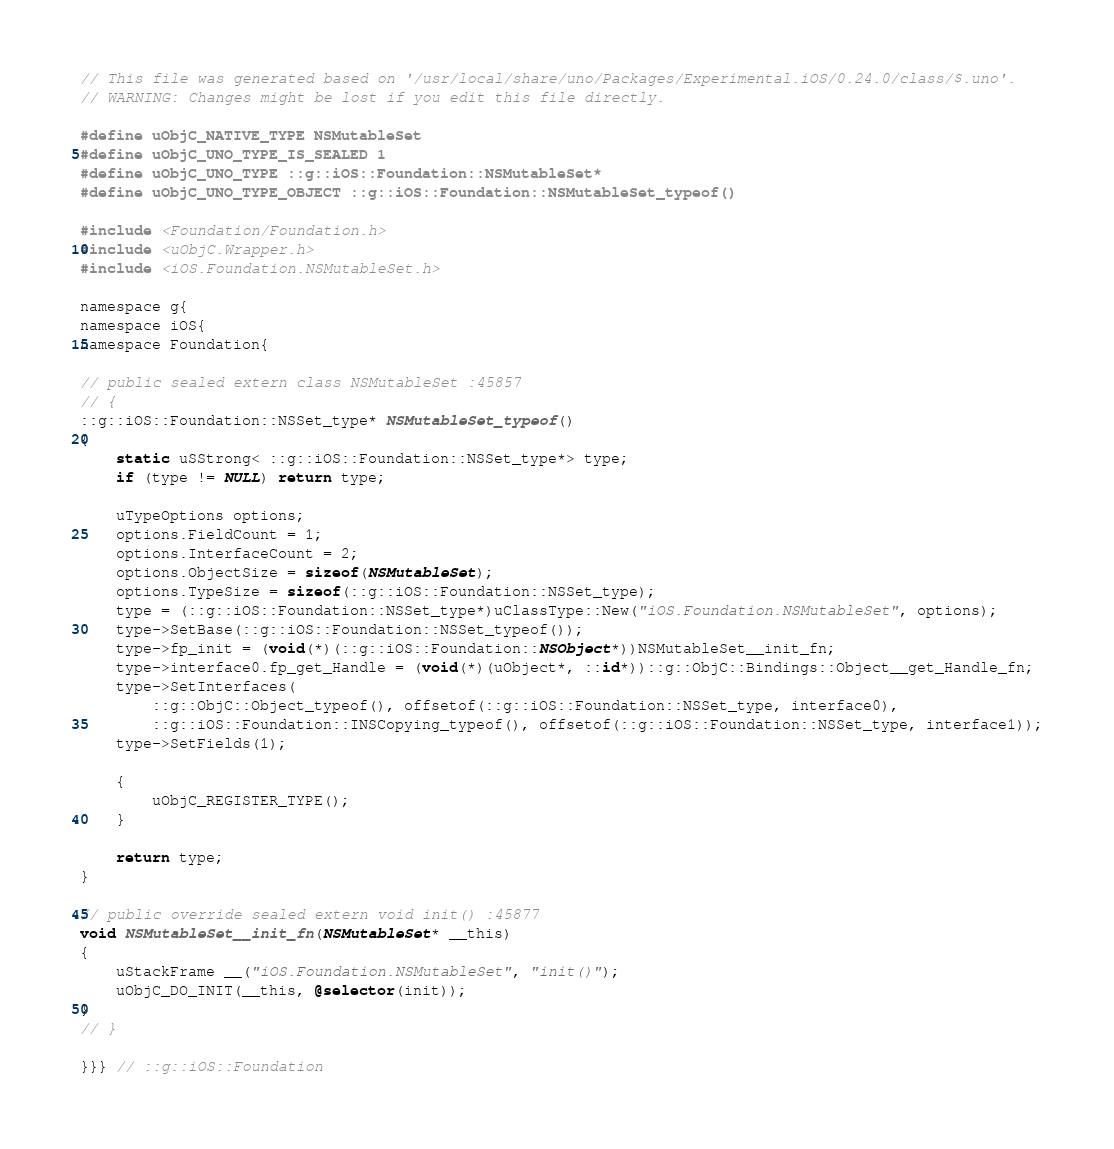Convert code to text. <code><loc_0><loc_0><loc_500><loc_500><_ObjectiveC_>// This file was generated based on '/usr/local/share/uno/Packages/Experimental.iOS/0.24.0/class/$.uno'.
// WARNING: Changes might be lost if you edit this file directly.

#define uObjC_NATIVE_TYPE NSMutableSet
#define uObjC_UNO_TYPE_IS_SEALED 1
#define uObjC_UNO_TYPE ::g::iOS::Foundation::NSMutableSet*
#define uObjC_UNO_TYPE_OBJECT ::g::iOS::Foundation::NSMutableSet_typeof()

#include <Foundation/Foundation.h>
#include <uObjC.Wrapper.h>
#include <iOS.Foundation.NSMutableSet.h>

namespace g{
namespace iOS{
namespace Foundation{

// public sealed extern class NSMutableSet :45857
// {
::g::iOS::Foundation::NSSet_type* NSMutableSet_typeof()
{
    static uSStrong< ::g::iOS::Foundation::NSSet_type*> type;
    if (type != NULL) return type;

    uTypeOptions options;
    options.FieldCount = 1;
    options.InterfaceCount = 2;
    options.ObjectSize = sizeof(NSMutableSet);
    options.TypeSize = sizeof(::g::iOS::Foundation::NSSet_type);
    type = (::g::iOS::Foundation::NSSet_type*)uClassType::New("iOS.Foundation.NSMutableSet", options);
    type->SetBase(::g::iOS::Foundation::NSSet_typeof());
    type->fp_init = (void(*)(::g::iOS::Foundation::NSObject*))NSMutableSet__init_fn;
    type->interface0.fp_get_Handle = (void(*)(uObject*, ::id*))::g::ObjC::Bindings::Object__get_Handle_fn;
    type->SetInterfaces(
        ::g::ObjC::Object_typeof(), offsetof(::g::iOS::Foundation::NSSet_type, interface0),
        ::g::iOS::Foundation::INSCopying_typeof(), offsetof(::g::iOS::Foundation::NSSet_type, interface1));
    type->SetFields(1);

    {
        uObjC_REGISTER_TYPE();
    }

    return type;
}

// public override sealed extern void init() :45877
void NSMutableSet__init_fn(NSMutableSet* __this)
{
    uStackFrame __("iOS.Foundation.NSMutableSet", "init()");
    uObjC_DO_INIT(__this, @selector(init));
}
// }

}}} // ::g::iOS::Foundation
</code> 